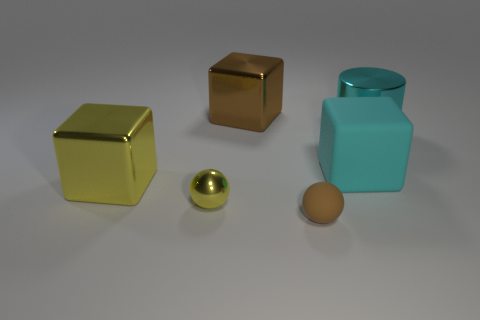How many other things are there of the same shape as the brown rubber thing?
Make the answer very short. 1. Is the number of cylinders that are to the right of the large shiny cylinder greater than the number of blue rubber blocks?
Offer a very short reply. No. What color is the thing that is behind the cyan cylinder?
Offer a terse response. Brown. There is a rubber thing that is the same color as the large metallic cylinder; what size is it?
Keep it short and to the point. Large. What number of matte objects are either gray objects or tiny brown spheres?
Offer a very short reply. 1. Are there any yellow metallic blocks that are to the right of the block that is to the right of the metal block that is behind the large cyan shiny thing?
Make the answer very short. No. There is a large yellow metal thing; how many tiny brown matte objects are left of it?
Provide a short and direct response. 0. There is a large block that is the same color as the big cylinder; what is its material?
Ensure brevity in your answer.  Rubber. How many small things are either blue balls or cubes?
Provide a succinct answer. 0. There is a brown thing that is in front of the tiny yellow shiny thing; what is its shape?
Provide a succinct answer. Sphere. 